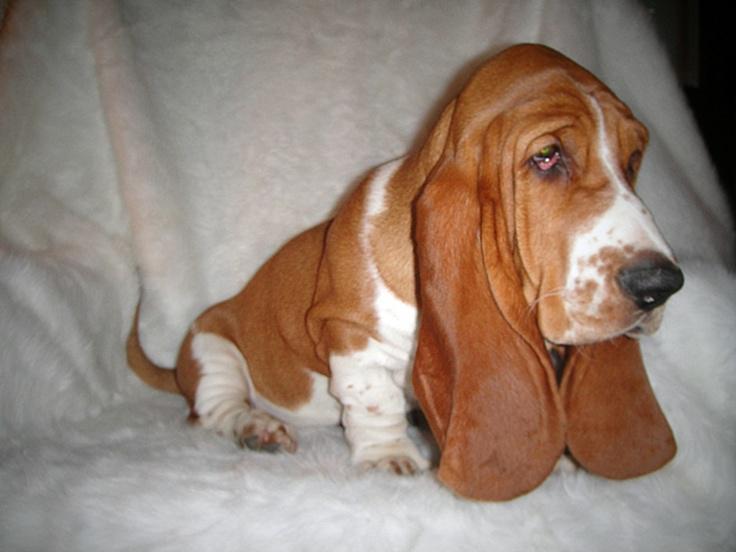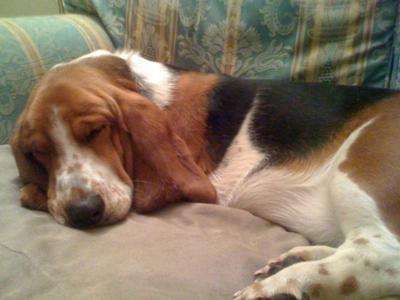The first image is the image on the left, the second image is the image on the right. Evaluate the accuracy of this statement regarding the images: "The right image includes a tri-color dog in an upright profile pose with its front paws raised off the ground.". Is it true? Answer yes or no. No. The first image is the image on the left, the second image is the image on the right. Given the left and right images, does the statement "One of the images shows a dog with its two front paws off the ground." hold true? Answer yes or no. No. 